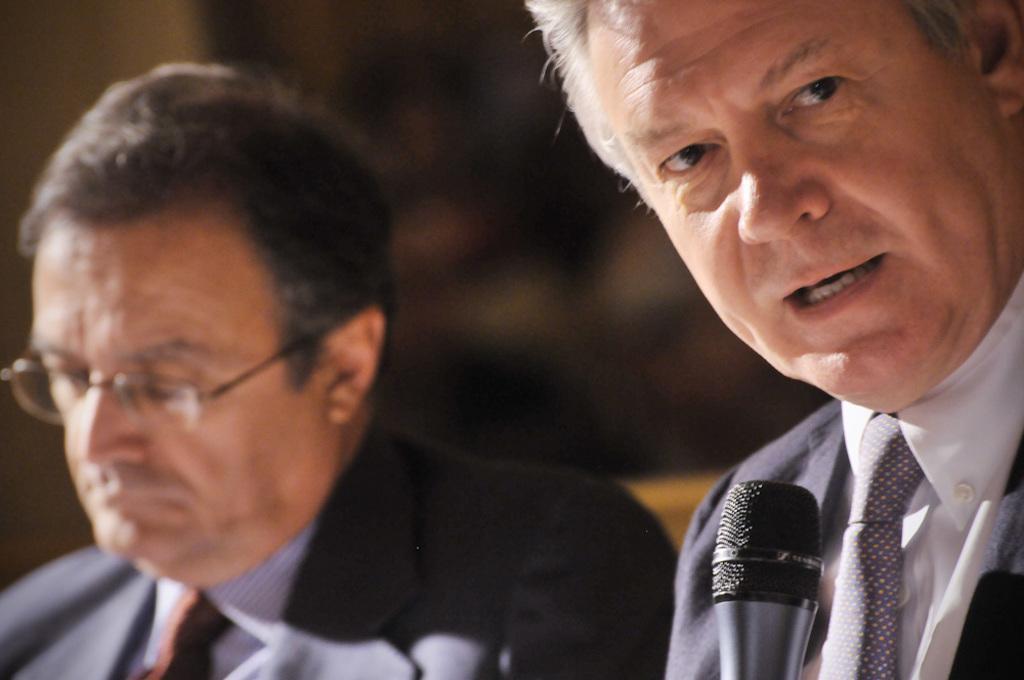Could you give a brief overview of what you see in this image? In this image, there are a few people. We can also see the blurred background. 